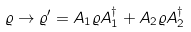Convert formula to latex. <formula><loc_0><loc_0><loc_500><loc_500>\varrho \rightarrow \varrho ^ { \prime } = A _ { 1 } \varrho A _ { 1 } ^ { \dagger } + A _ { 2 } \varrho A _ { 2 } ^ { \dagger }</formula> 